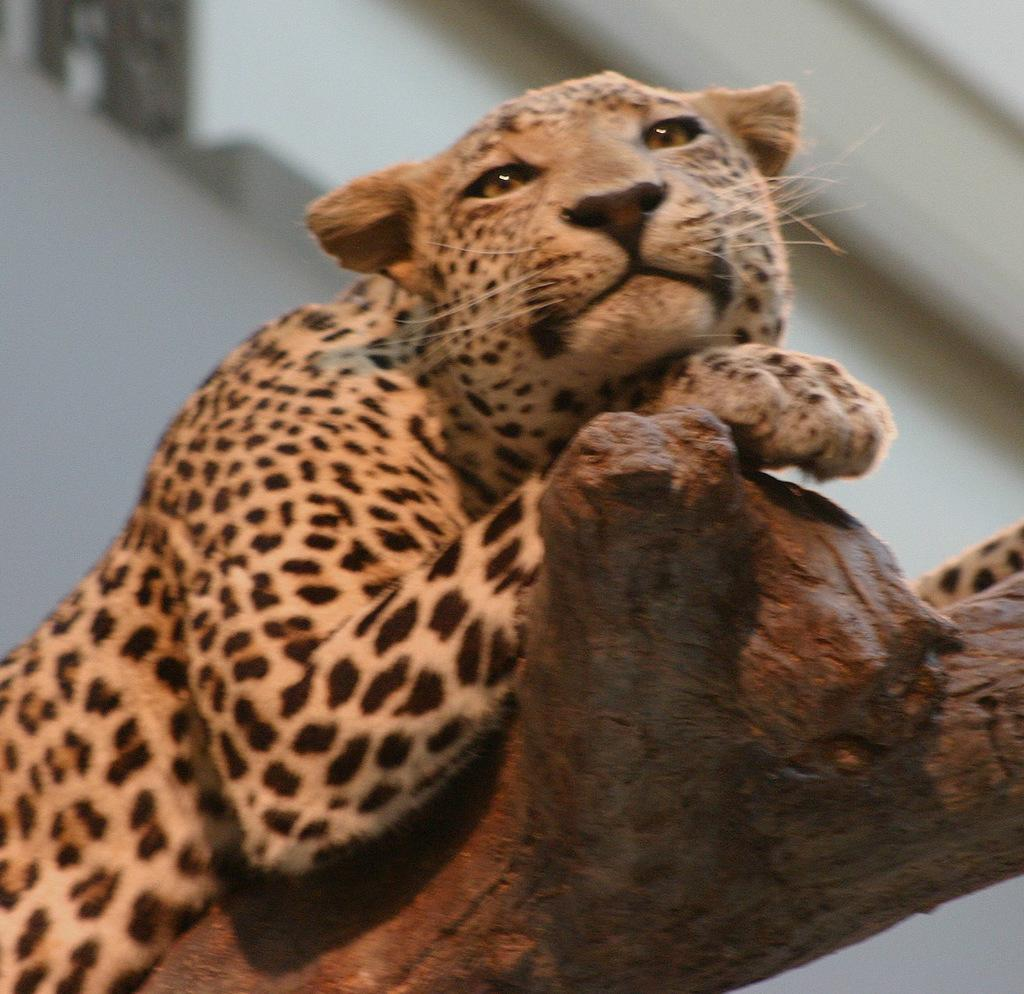What animal is in the foreground of the picture? There is a cheetah in the foreground of the picture. Where is the cheetah located? The cheetah is on the trunk of a tree. Can you describe the background of the image? The background of the image is blurred. What substance is being used to enhance the flavor of the cheetah in the image? There is no substance being used to enhance the flavor of the cheetah in the image, as it is a wild animal and not a food item. 